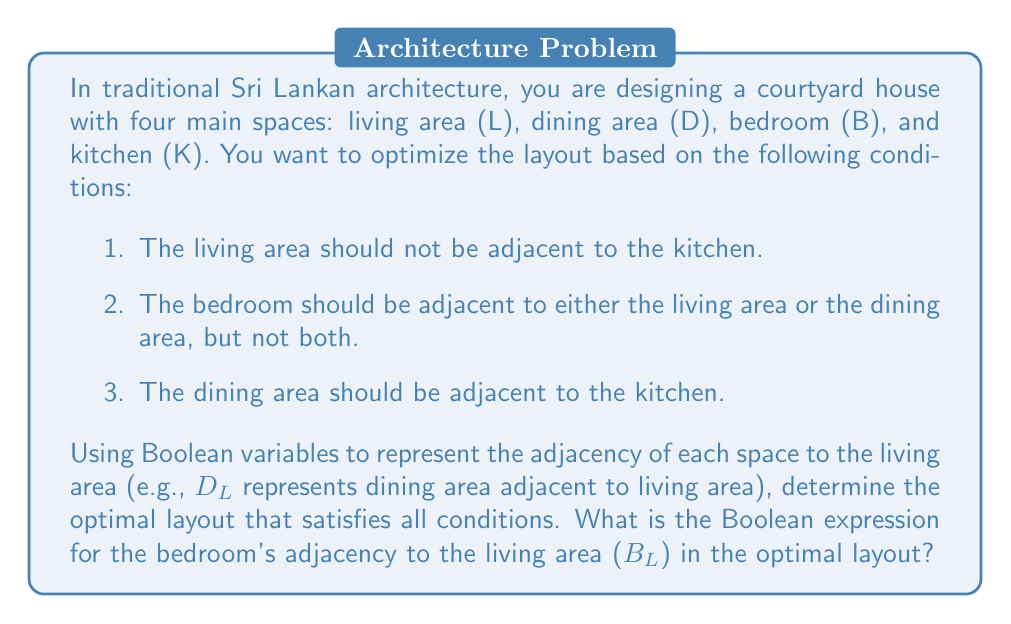Provide a solution to this math problem. Let's approach this step-by-step using Boolean logic:

1. We'll use the following variables:
   $L_D$: Living area adjacent to dining area
   $L_B$: Living area adjacent to bedroom
   $L_K$: Living area adjacent to kitchen
   $D_B$: Dining area adjacent to bedroom
   $D_K$: Dining area adjacent to kitchen
   $B_K$: Bedroom adjacent to kitchen

2. From the given conditions:
   a. $L_K = 0$ (Living area not adjacent to kitchen)
   b. $L_B \oplus D_B = 1$ (Bedroom adjacent to either living or dining, but not both)
   c. $D_K = 1$ (Dining area adjacent to kitchen)

3. To optimize the layout, we need to minimize the number of adjacencies while satisfying all conditions. Let's consider the possible arrangements:

   Case 1: $L_B = 1, D_B = 0$
   Case 2: $L_B = 0, D_B = 1$

4. For Case 1 ($L_B = 1, D_B = 0$):
   - $L_D$ must be 0 to keep the layout compact
   - $B_K$ must be 0 to satisfy condition (a)
   The layout would be: L - B - D - K

5. For Case 2 ($L_B = 0, D_B = 1$):
   - $L_D$ must be 1 to connect all spaces
   - $B_K$ can be 1, allowing for a more compact layout
   The layout would be: L - D - B
                            |
                            K

6. Case 2 provides a more compact and efficient layout while satisfying all conditions.

7. Therefore, in the optimal layout, $B_L = 0$ (Bedroom is not adjacent to the living area).

The Boolean expression for the bedroom's adjacency to the living area ($B_L$) in the optimal layout is simply 0.
Answer: 0 